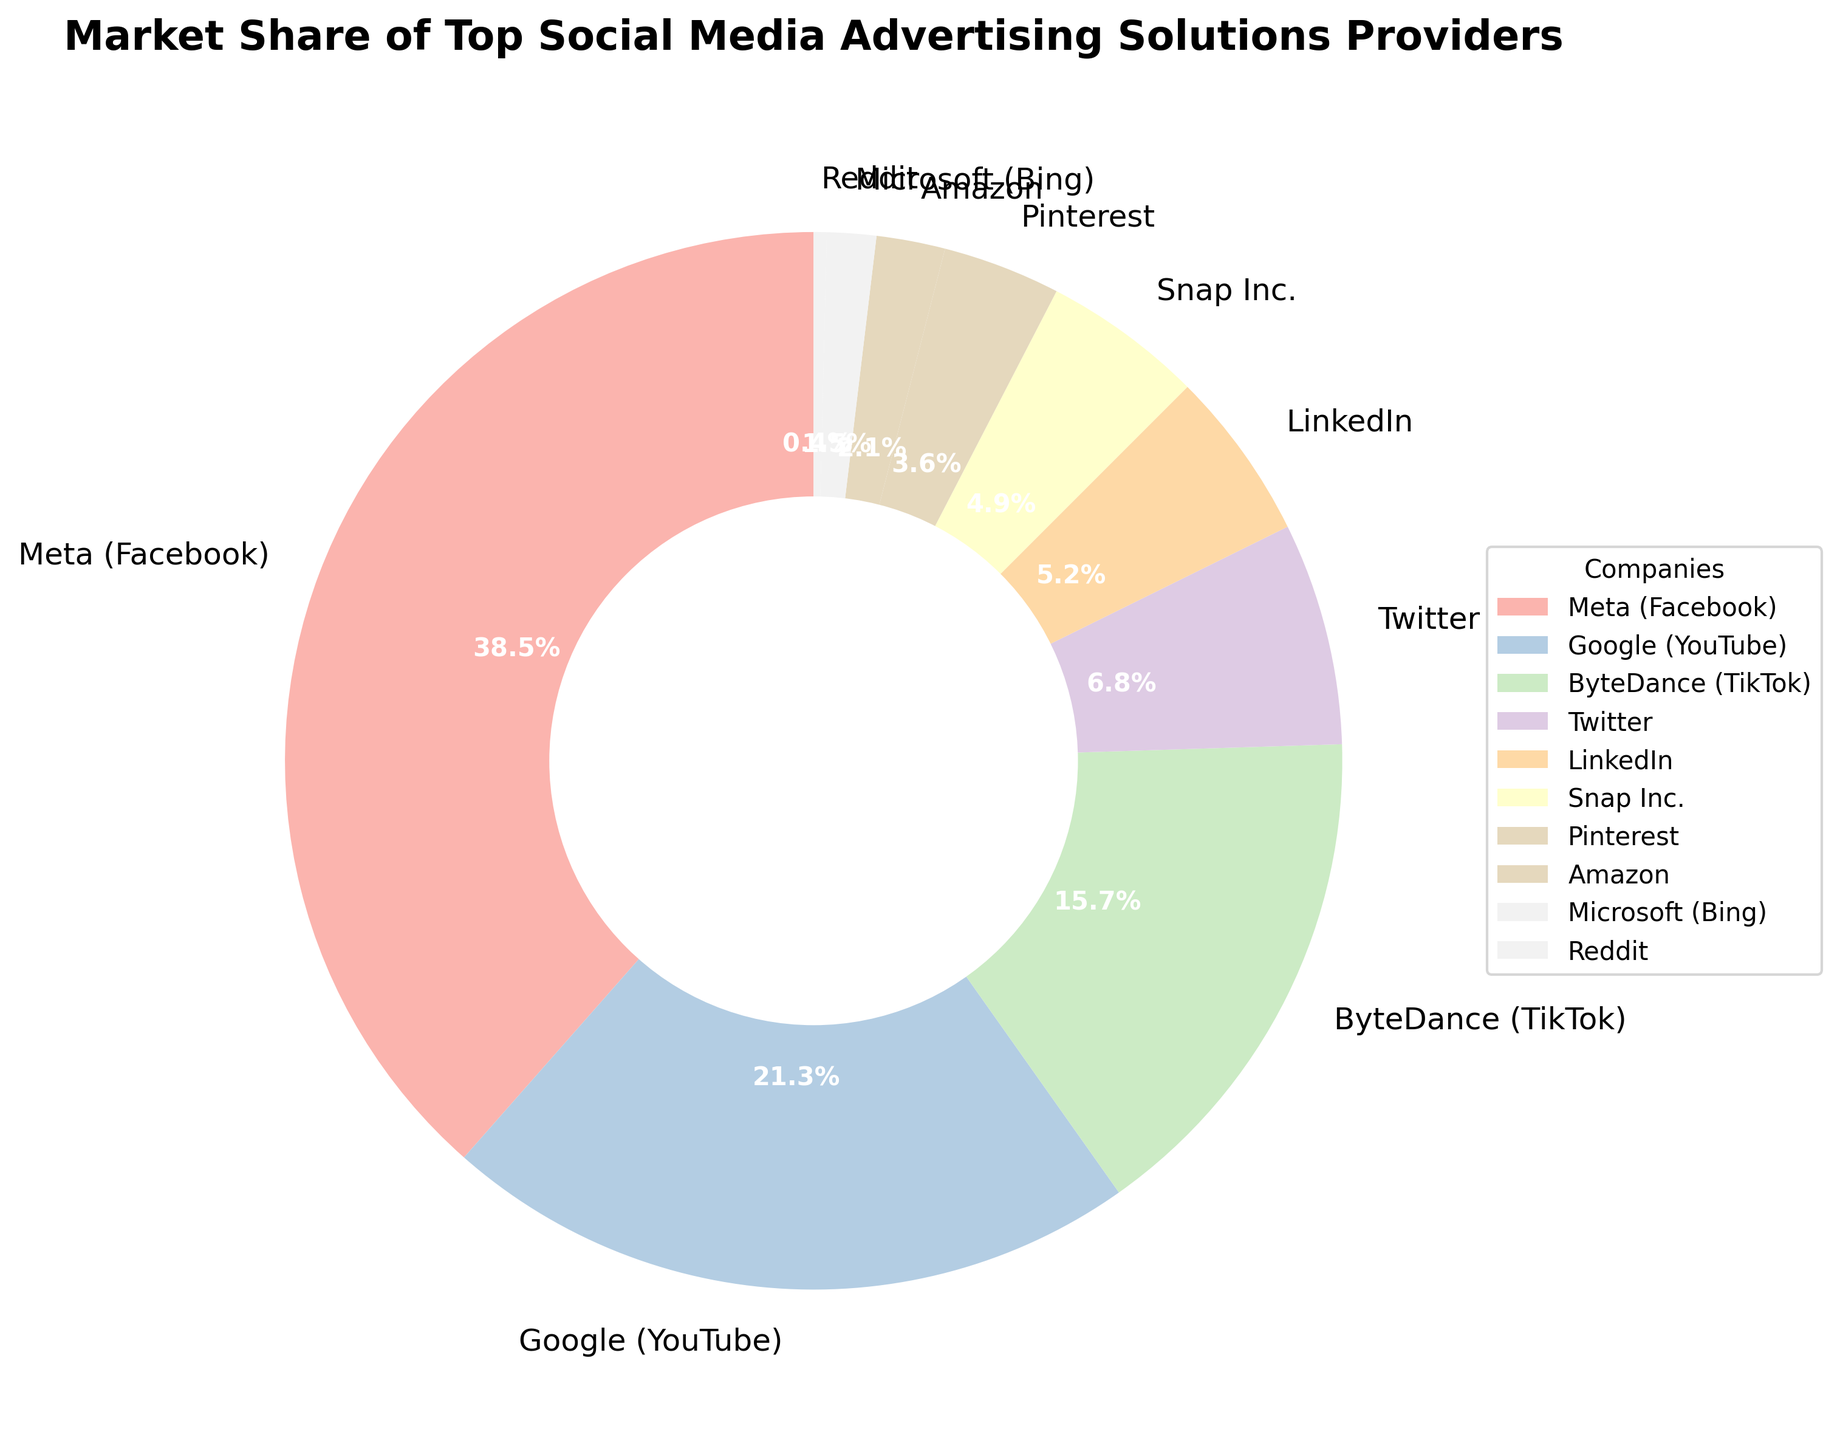What's the company with the largest market share? The sectors in the pie chart are labeled with company names and market share figures. Identifying the largest sector visually or by reading the number reveals the company with the largest share, which is Meta (Facebook) at 38.5%.
Answer: Meta (Facebook) Which two companies have the smallest market shares? The smallest sectors in the pie chart can be identified by comparing the sizes of all sectors. The companies with the smallest market shares are Microsoft (Bing) with 1.5% and Reddit with 0.4%.
Answer: Microsoft (Bing) and Reddit What is the combined market share of ByteDance (TikTok) and Twitter? Locate ByteDance (TikTok) and Twitter sectors; ByteDance has 15.7% and Twitter has 6.8%. Summing these gives a combined market share of 15.7% + 6.8% = 22.5%.
Answer: 22.5% What is the approximate difference in market share between Google (YouTube) and Snap Inc.? Google (YouTube) has a market share of 21.3% and Snap Inc. has 4.9%. The difference is 21.3% - 4.9% = 16.4%.
Answer: 16.4% Which companies have a market share greater than 5%? Scan the pie chart for companies with market shares labeled above 5%. These companies are Meta (Facebook), Google (YouTube), ByteDance (TikTok), and Twitter.
Answer: Meta (Facebook), Google (YouTube), ByteDance (TikTok), and Twitter Compare the market share of Pinterest with LinkedIn. Which one has a higher market share? Locate the sectors for Pinterest and LinkedIn. Pinterest has a market share of 3.6%, while LinkedIn has a market share of 5.2%. LinkedIn's market share is higher.
Answer: LinkedIn What's the average market share of Amazon and Microsoft (Bing)? Identify market shares for Amazon (2.1%) and Microsoft (Bing) (1.5%). The average is calculated by (2.1% + 1.5%) / 2 = 1.8%.
Answer: 1.8% What's the sum of market shares for Google (YouTube), ByteDance (TikTok), and Twitter? Identify market shares: Google (YouTube) 21.3%, ByteDance (TikTok) 15.7%, Twitter 6.8%. Sum them up: 21.3% + 15.7% + 6.8% = 43.8%.
Answer: 43.8% Which company's section appears between Meta (Facebook) and ByteDance (TikTok) in the pie chart? Visual inspection and labels indicate that Google (YouTube) is positioned between Meta (Facebook) and ByteDance (TikTok) when reading clockwise from Meta.
Answer: Google (YouTube) 